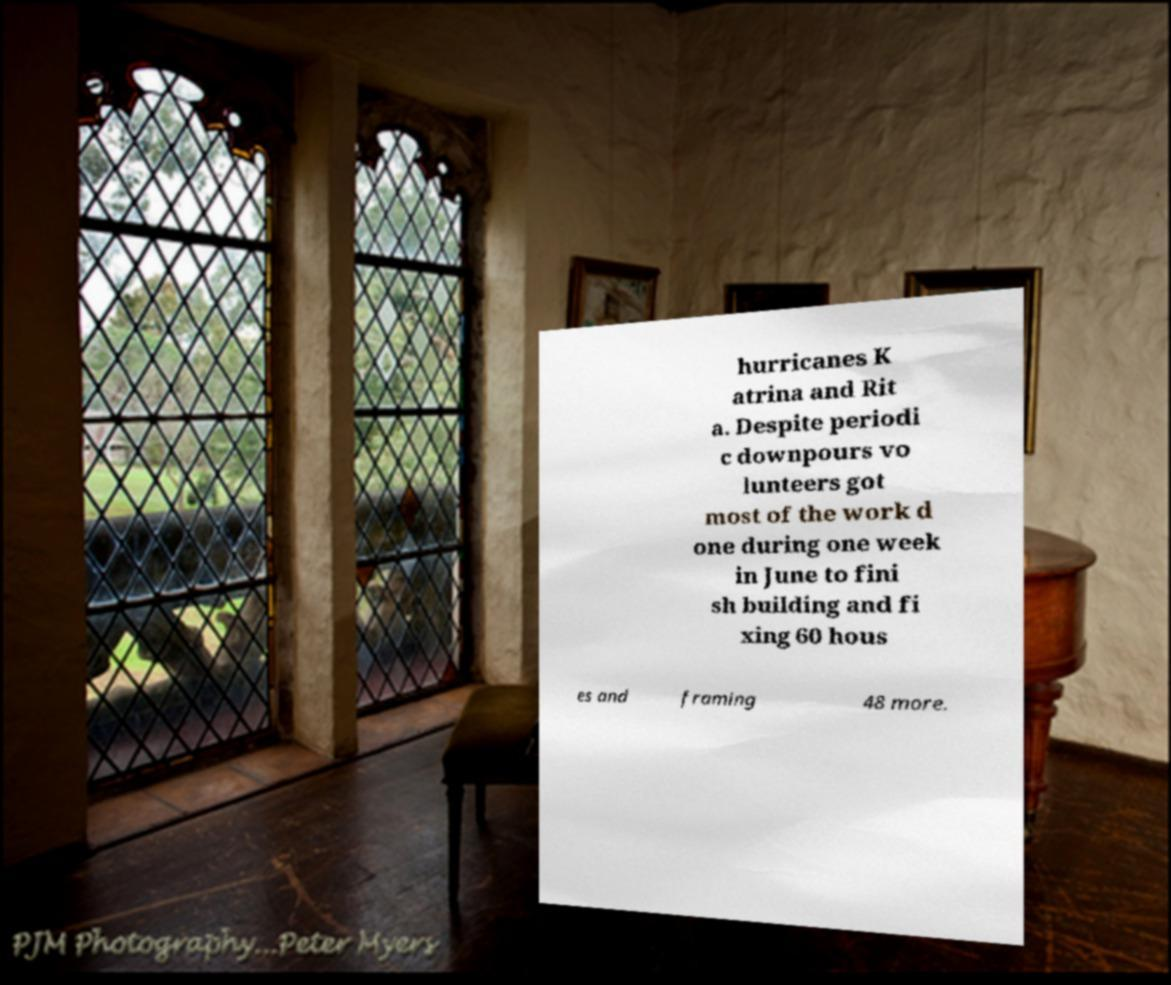Could you assist in decoding the text presented in this image and type it out clearly? hurricanes K atrina and Rit a. Despite periodi c downpours vo lunteers got most of the work d one during one week in June to fini sh building and fi xing 60 hous es and framing 48 more. 